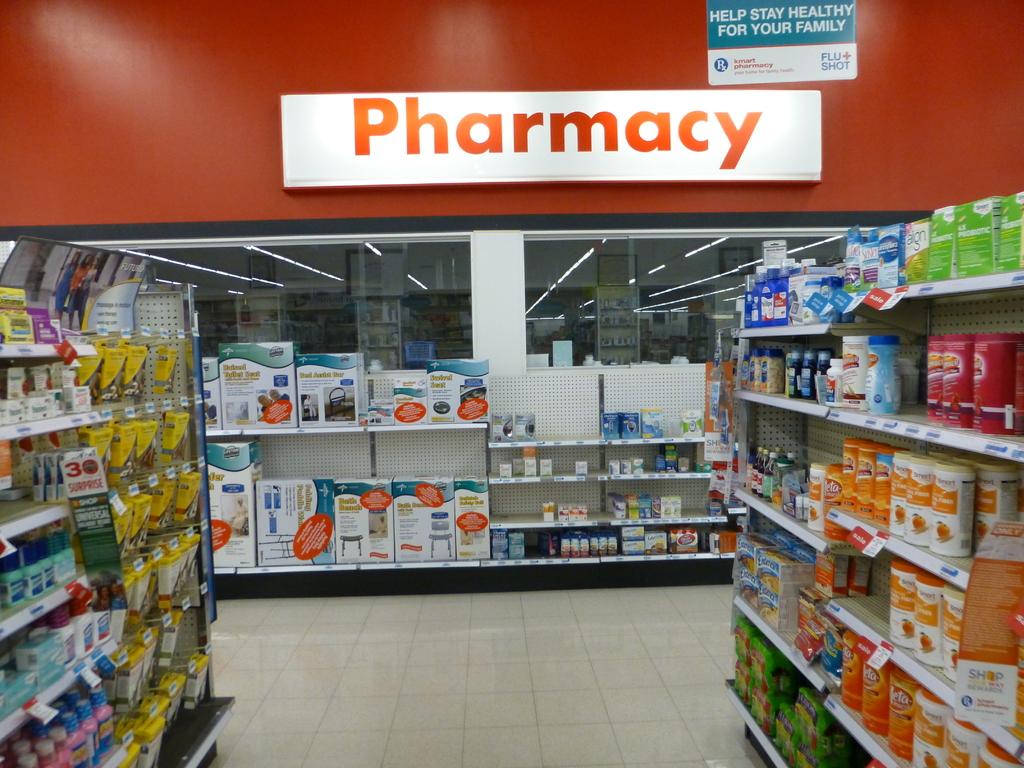Which department is this?
Ensure brevity in your answer.  Pharmacy. 